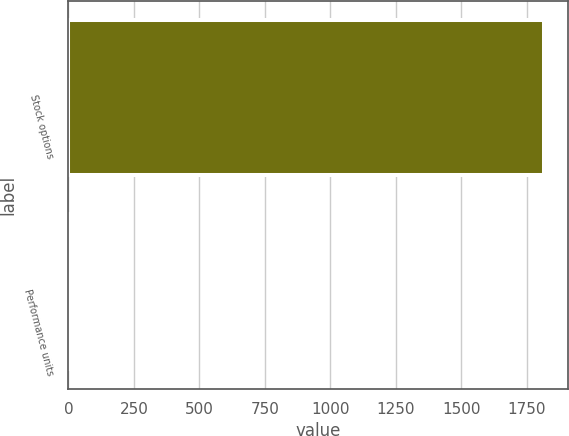Convert chart to OTSL. <chart><loc_0><loc_0><loc_500><loc_500><bar_chart><fcel>Stock options<fcel>Performance units<nl><fcel>1816<fcel>5<nl></chart> 